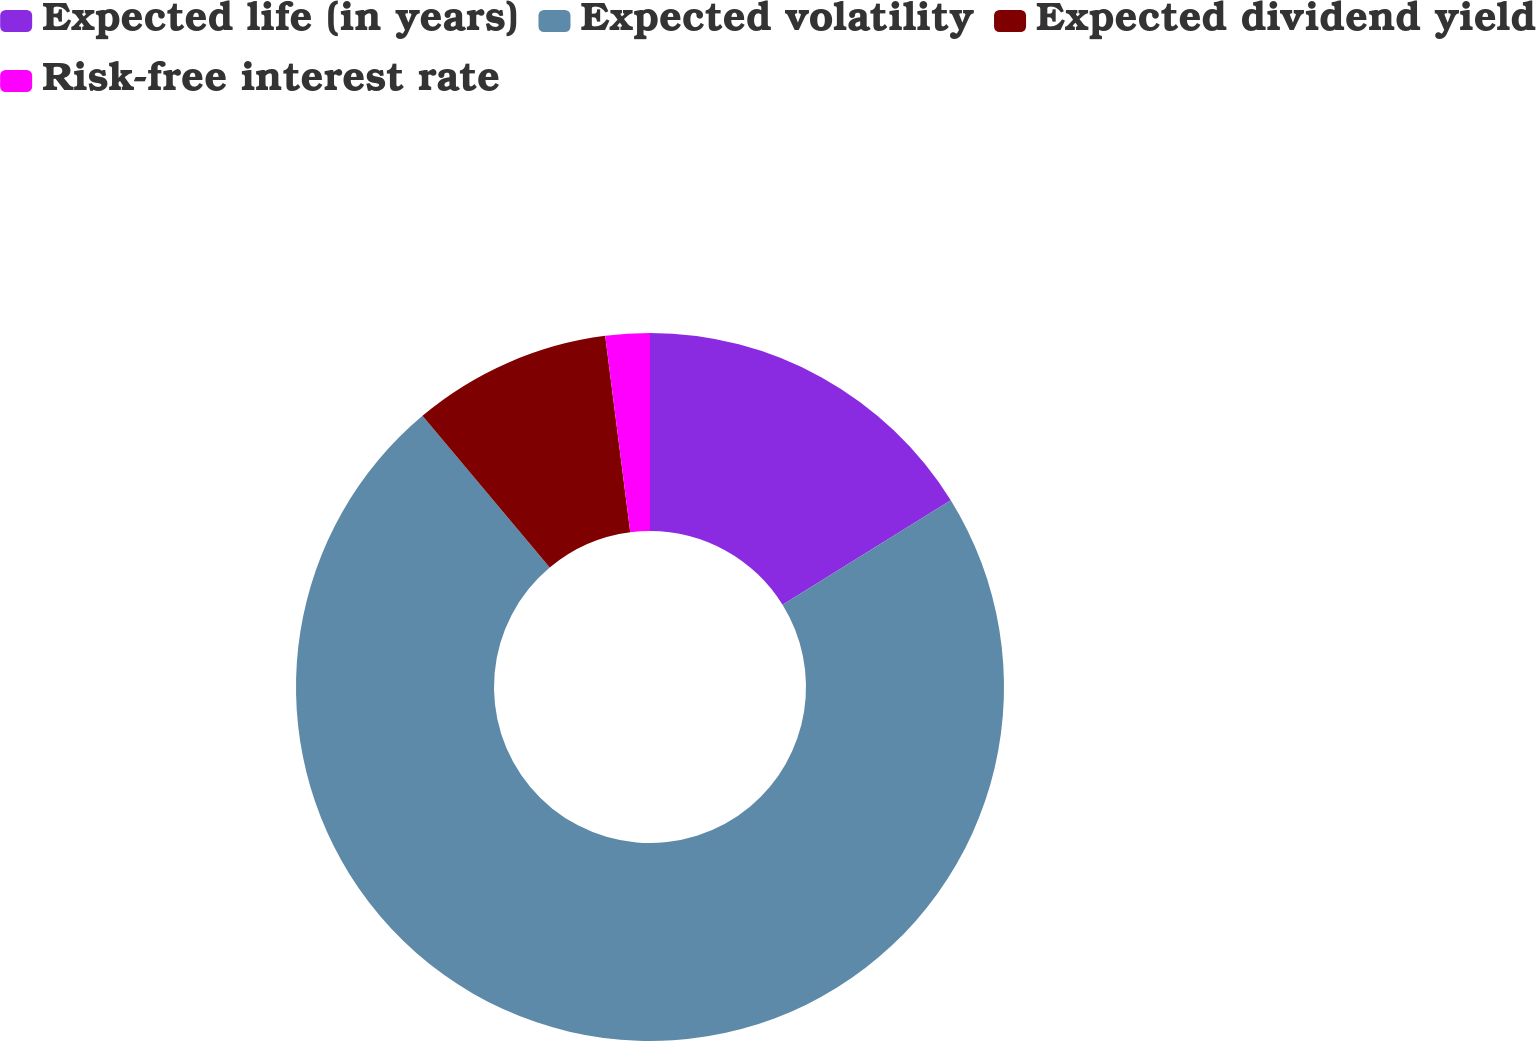Convert chart to OTSL. <chart><loc_0><loc_0><loc_500><loc_500><pie_chart><fcel>Expected life (in years)<fcel>Expected volatility<fcel>Expected dividend yield<fcel>Risk-free interest rate<nl><fcel>16.16%<fcel>72.73%<fcel>9.09%<fcel>2.02%<nl></chart> 